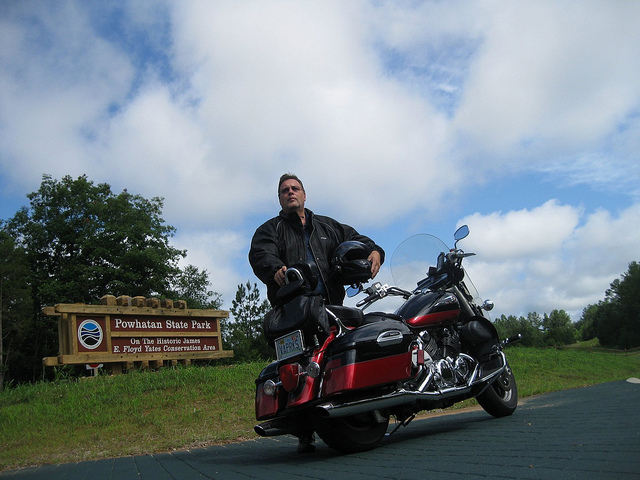Read and extract the text from this image. Powhatan Park State Area James Conservative Floyd E Historic The On 